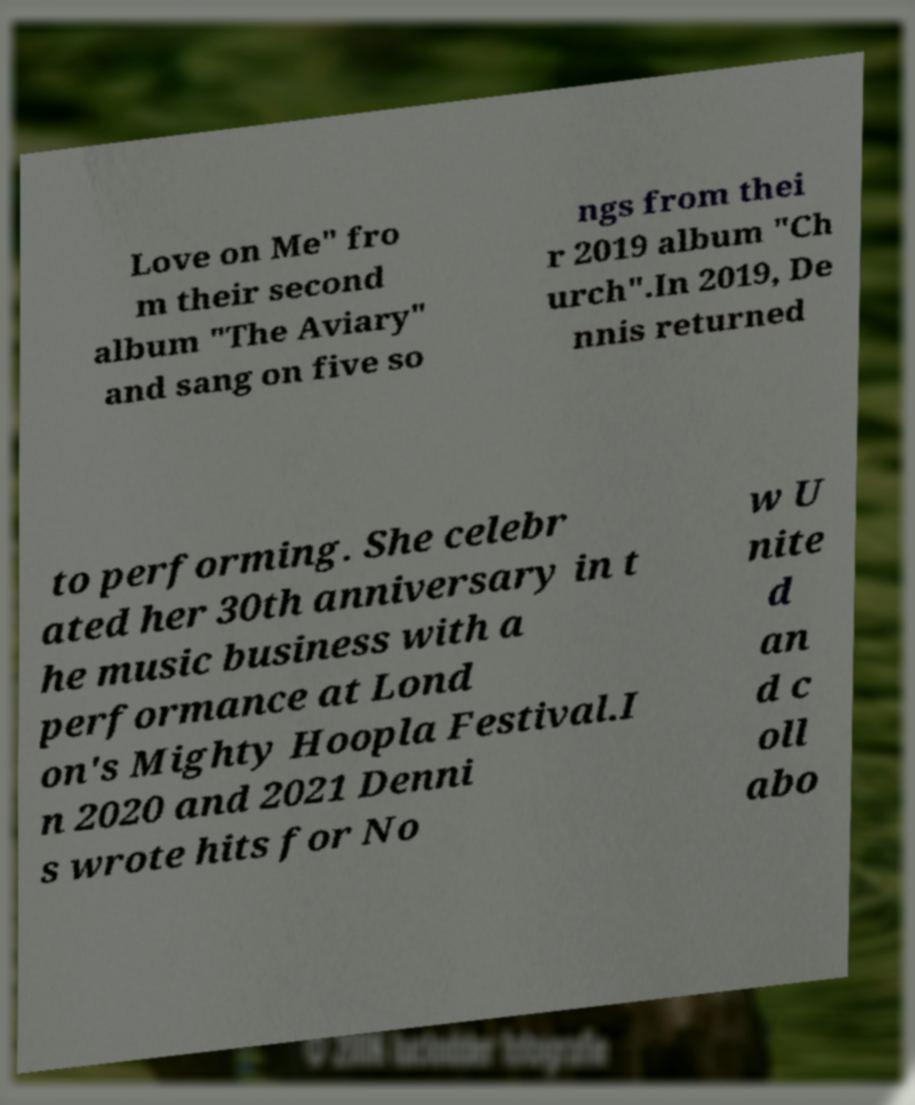What messages or text are displayed in this image? I need them in a readable, typed format. Love on Me" fro m their second album "The Aviary" and sang on five so ngs from thei r 2019 album "Ch urch".In 2019, De nnis returned to performing. She celebr ated her 30th anniversary in t he music business with a performance at Lond on's Mighty Hoopla Festival.I n 2020 and 2021 Denni s wrote hits for No w U nite d an d c oll abo 